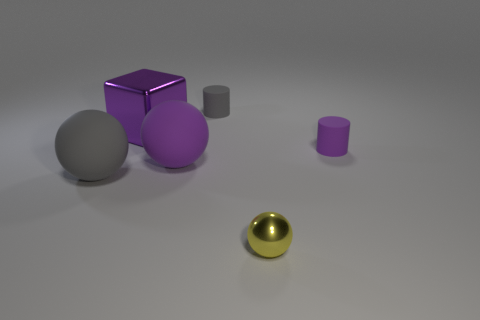Add 2 gray rubber cylinders. How many objects exist? 8 Subtract all gray balls. Subtract all red cylinders. How many balls are left? 2 Subtract all cubes. How many objects are left? 5 Add 2 large gray blocks. How many large gray blocks exist? 2 Subtract 1 purple balls. How many objects are left? 5 Subtract all yellow shiny balls. Subtract all spheres. How many objects are left? 2 Add 6 purple metallic cubes. How many purple metallic cubes are left? 7 